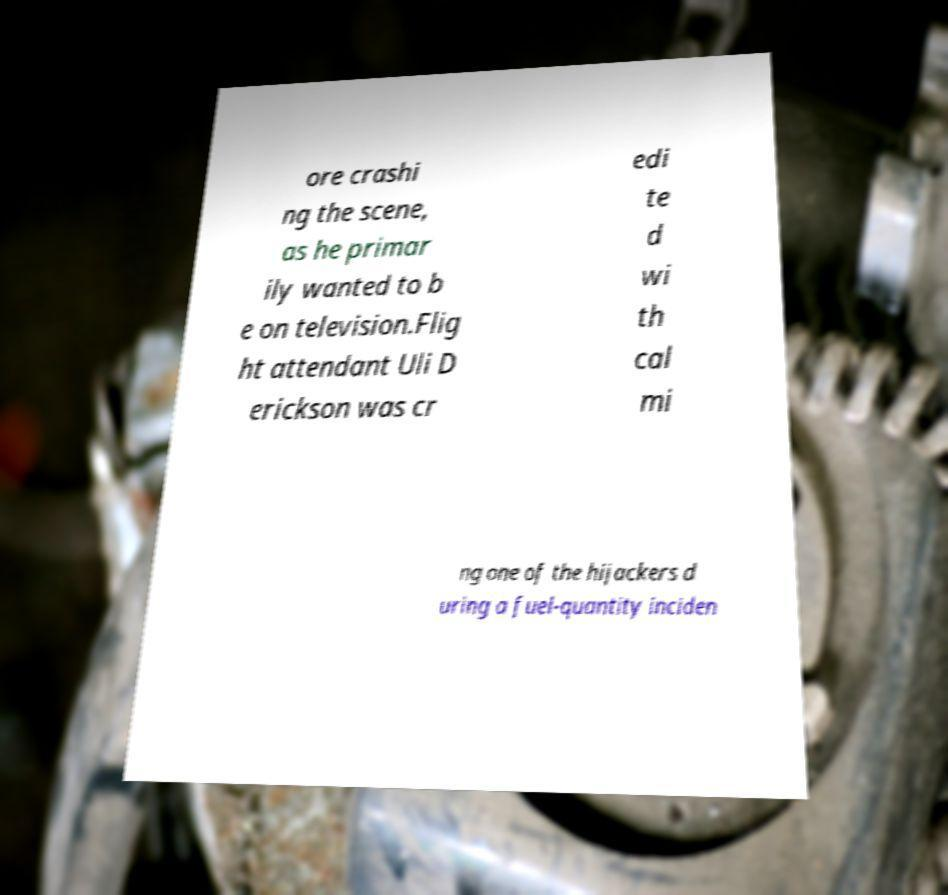Please identify and transcribe the text found in this image. ore crashi ng the scene, as he primar ily wanted to b e on television.Flig ht attendant Uli D erickson was cr edi te d wi th cal mi ng one of the hijackers d uring a fuel-quantity inciden 